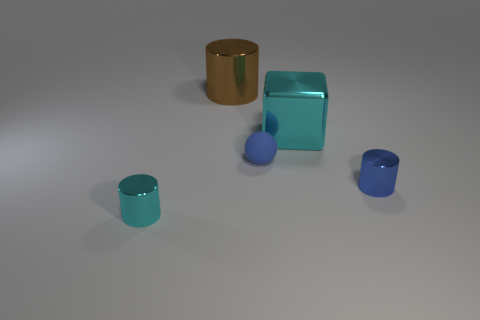Add 2 small blocks. How many objects exist? 7 Subtract all balls. How many objects are left? 4 Add 2 big cyan cubes. How many big cyan cubes exist? 3 Subtract 0 gray spheres. How many objects are left? 5 Subtract all tiny blue matte objects. Subtract all shiny blocks. How many objects are left? 3 Add 2 large metallic cylinders. How many large metallic cylinders are left? 3 